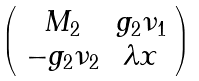Convert formula to latex. <formula><loc_0><loc_0><loc_500><loc_500>\left ( \begin{array} { c c } M _ { 2 } & g _ { 2 } \nu _ { 1 } \\ - g _ { 2 } \nu _ { 2 } & \lambda x \end{array} \right )</formula> 